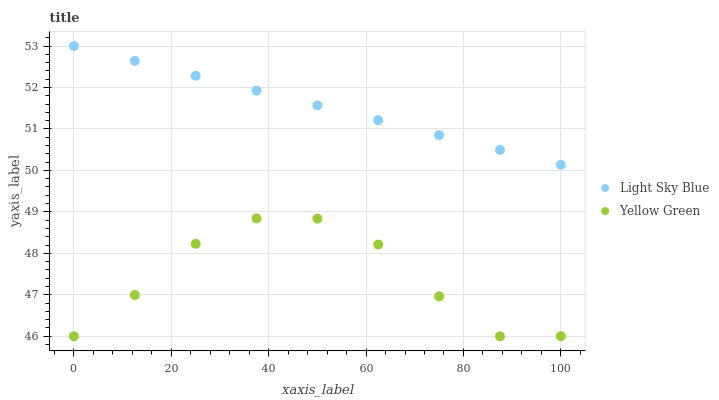Does Yellow Green have the minimum area under the curve?
Answer yes or no. Yes. Does Light Sky Blue have the maximum area under the curve?
Answer yes or no. Yes. Does Yellow Green have the maximum area under the curve?
Answer yes or no. No. Is Light Sky Blue the smoothest?
Answer yes or no. Yes. Is Yellow Green the roughest?
Answer yes or no. Yes. Is Yellow Green the smoothest?
Answer yes or no. No. Does Yellow Green have the lowest value?
Answer yes or no. Yes. Does Light Sky Blue have the highest value?
Answer yes or no. Yes. Does Yellow Green have the highest value?
Answer yes or no. No. Is Yellow Green less than Light Sky Blue?
Answer yes or no. Yes. Is Light Sky Blue greater than Yellow Green?
Answer yes or no. Yes. Does Yellow Green intersect Light Sky Blue?
Answer yes or no. No. 